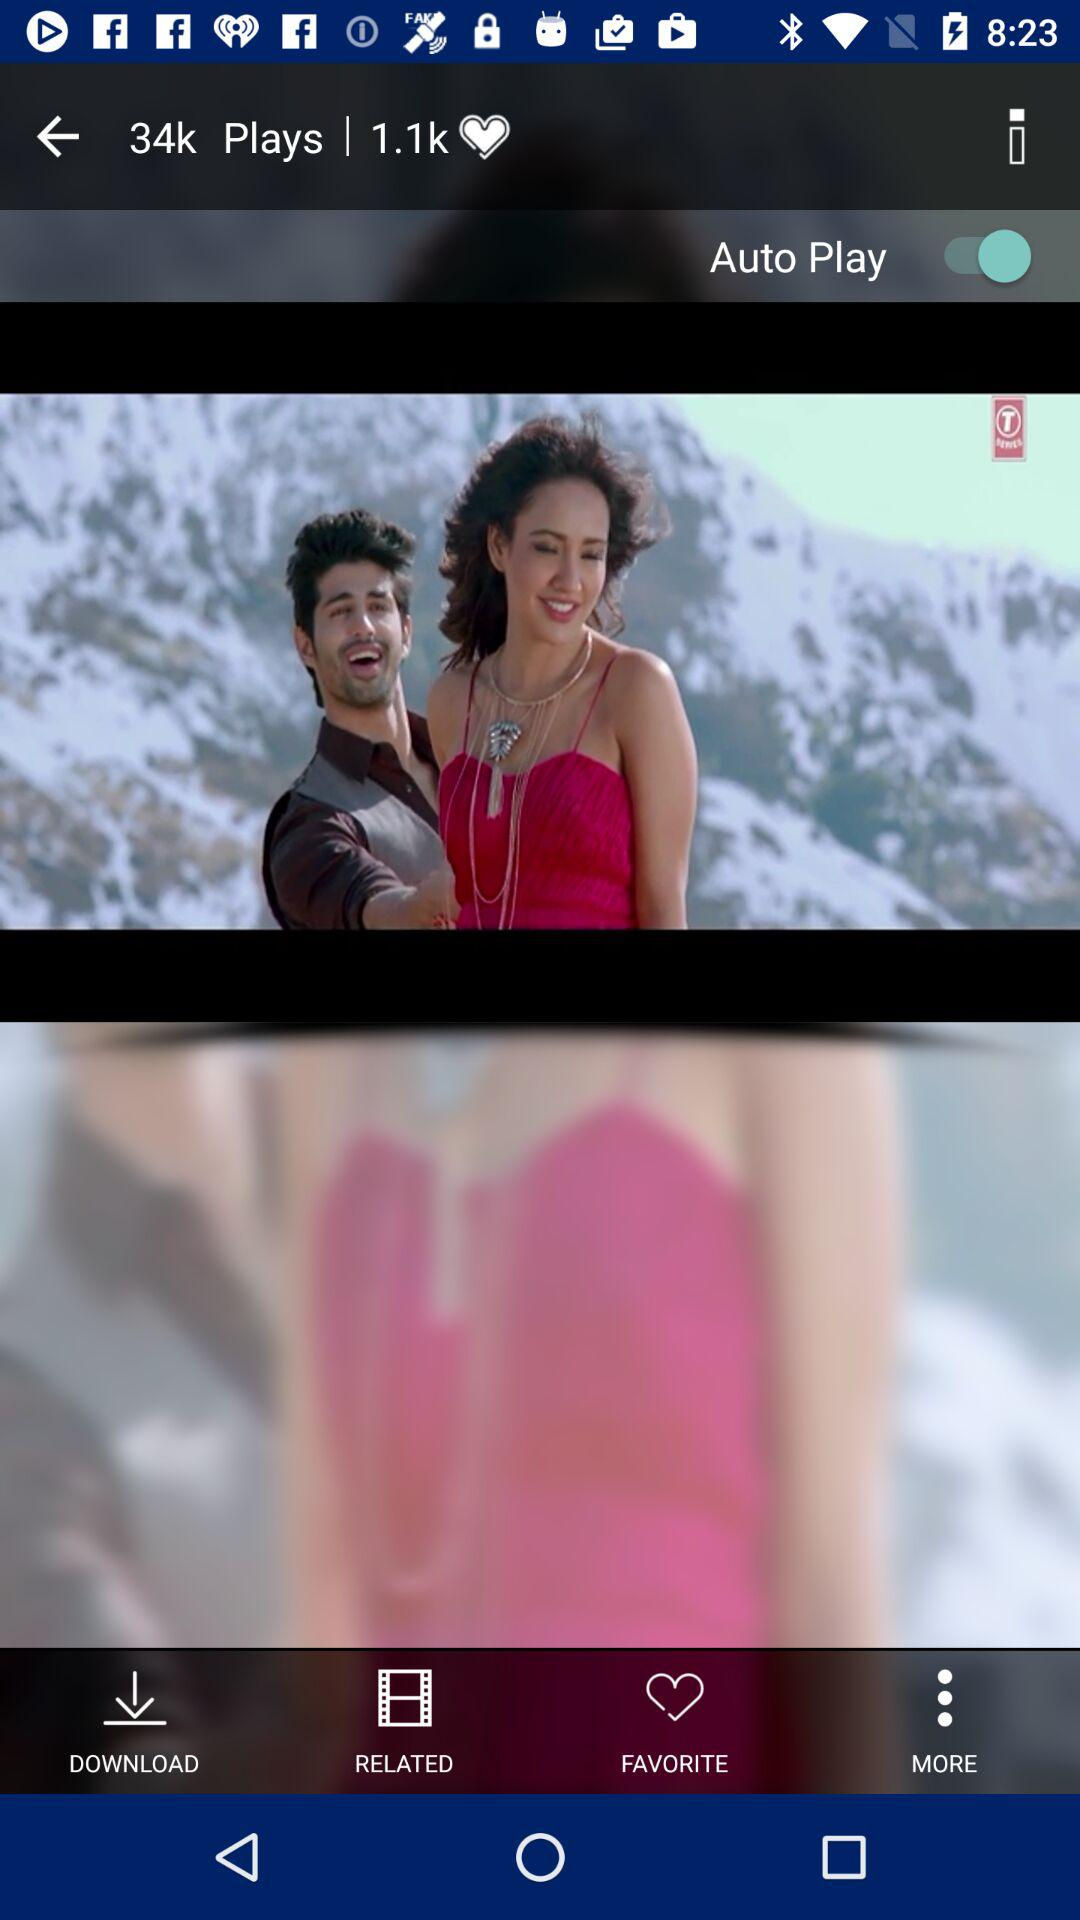How many number of likes are there? There are 1,10,000 likes. 